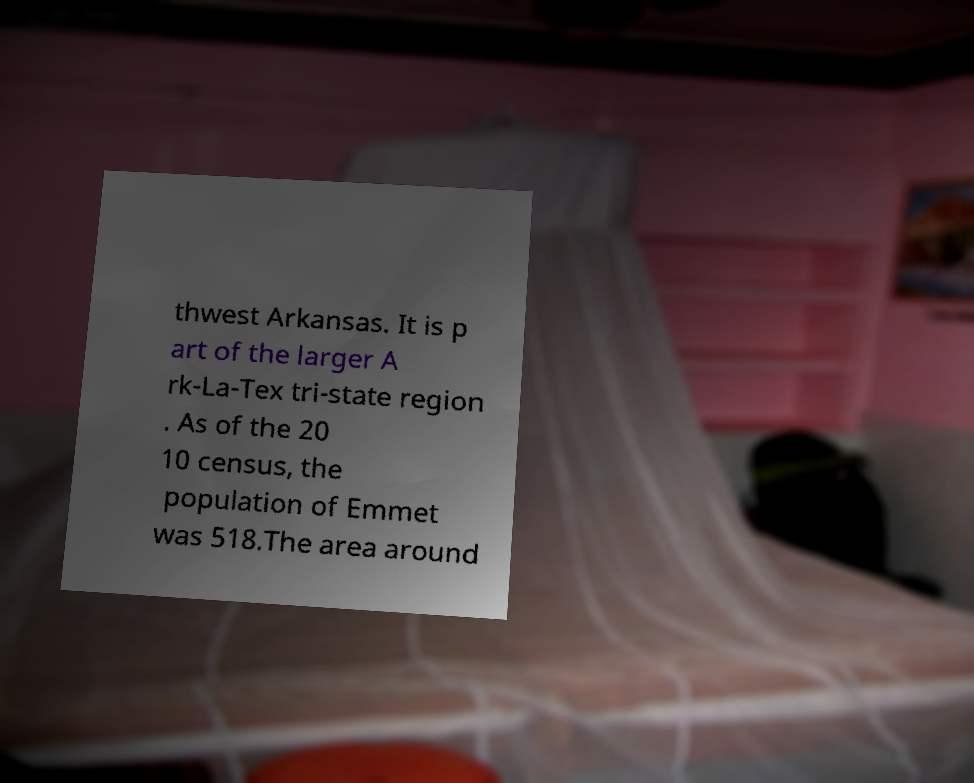I need the written content from this picture converted into text. Can you do that? thwest Arkansas. It is p art of the larger A rk-La-Tex tri-state region . As of the 20 10 census, the population of Emmet was 518.The area around 